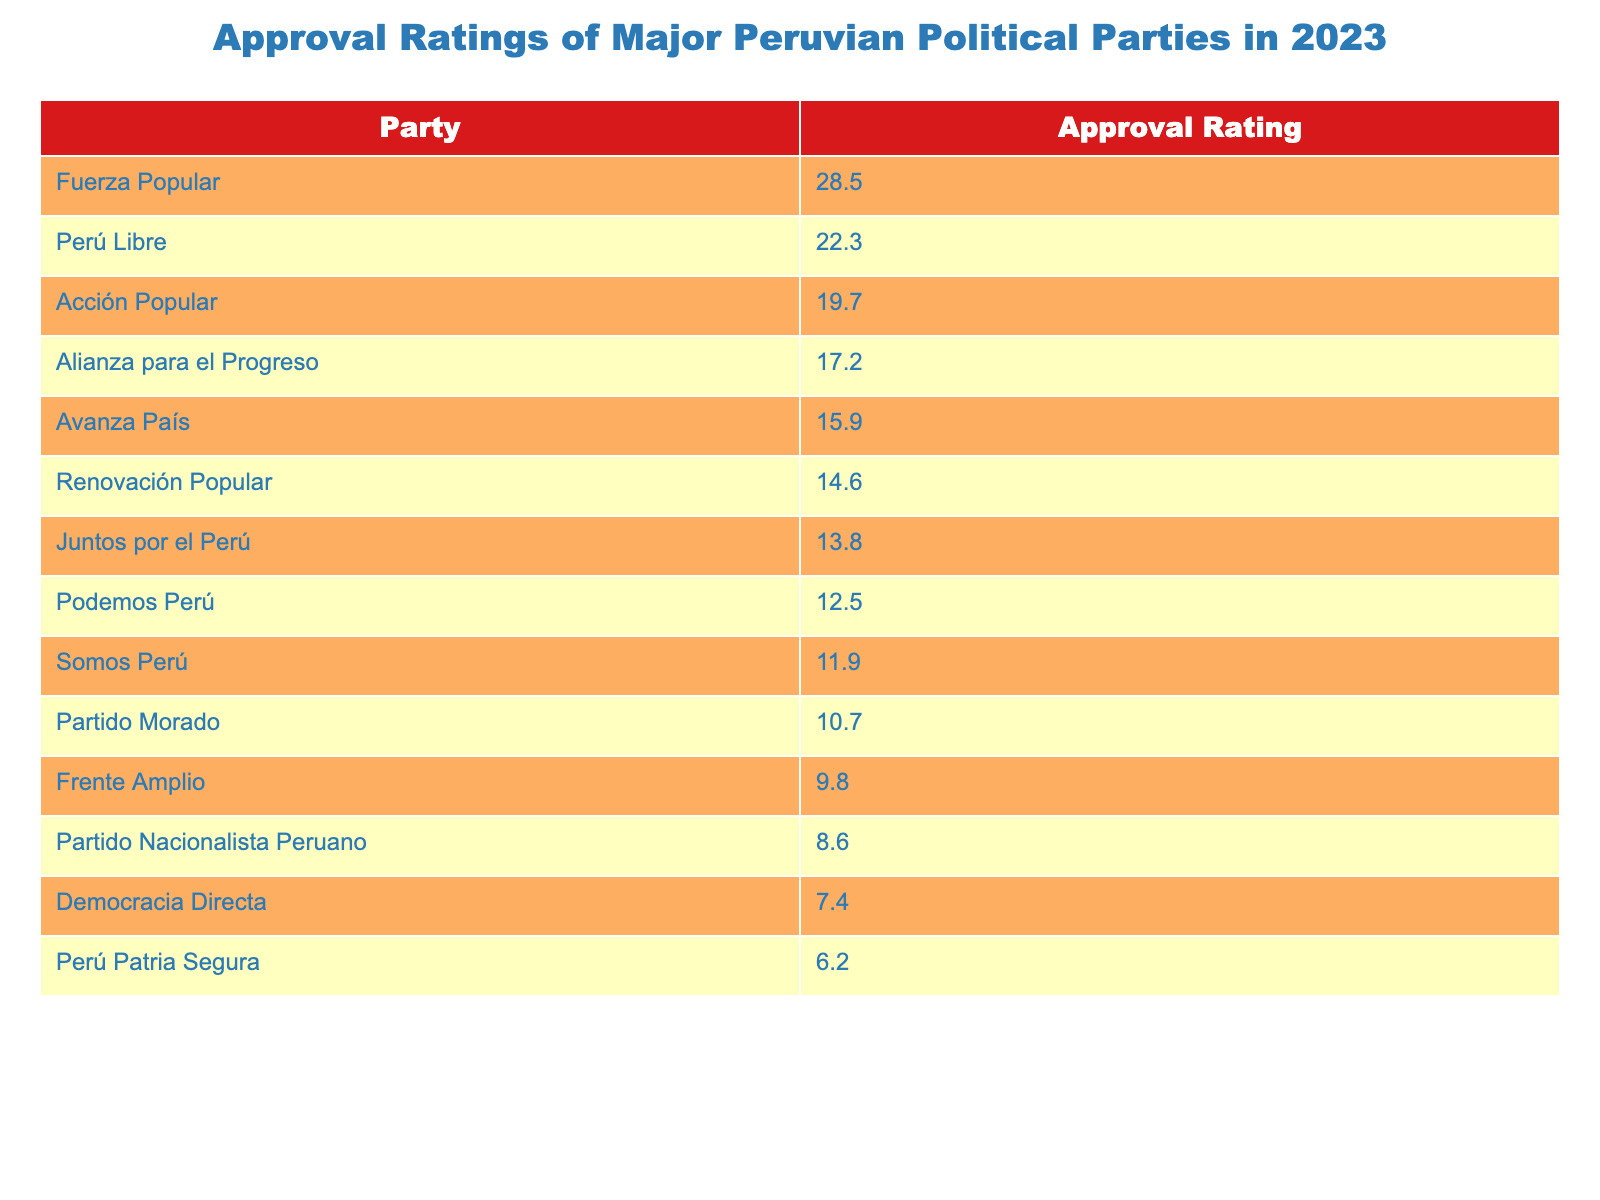What is the approval rating of Fuerza Popular? The table lists the approval rating for Fuerza Popular as 28.5.
Answer: 28.5 Which party has the lowest approval rating? By looking through the table, I find that Perú Patria Segura has the lowest approval rating at 6.2.
Answer: 6.2 What are the approval ratings of Alianza para el Progreso and Avanza País combined? The approval rating for Alianza para el Progreso is 17.2 and for Avanza País is 15.9. Summing these together gives 17.2 + 15.9 = 33.1.
Answer: 33.1 Is the approval rating of Juntos por el Perú higher than that of Podemos Perú? Juntos por el Perú has an approval rating of 13.8, while Podemos Perú has 12.5. Since 13.8 is greater than 12.5, the statement is true.
Answer: Yes What is the average approval rating of the parties listed in the table? To calculate the average, sum the approval ratings: (28.5 + 22.3 + 19.7 + 17.2 + 15.9 + 14.6 + 13.8 + 12.5 + 11.9 + 10.7 + 9.8 + 8.6 + 7.4 + 6.2) =  267.2. There are 14 parties, so the average is 267.2 / 14 = 19.1.
Answer: 19.1 How many parties have an approval rating above 20? By examining the table, I see that the parties with approval ratings above 20 are Fuerza Popular (28.5) and Perú Libre (22.3), which makes a total of 2 parties.
Answer: 2 What is the difference in approval ratings between Acción Popular and Renovación Popular? Acción Popular has an approval rating of 19.7 and Renovación Popular has 14.6. The difference is calculated as 19.7 - 14.6 = 5.1.
Answer: 5.1 Which party's approval rating is closer to 15? The closest approval rating to 15 is Avanza País at 15.9. Since it is the only one near 15, it can be concluded that it is the one being referred to.
Answer: Avanza País Is the approval rating of Partido Morado greater than the average of the top three parties? The top three parties are Fuerza Popular (28.5), Perú Libre (22.3), and Acción Popular (19.7). Their average is (28.5 + 22.3 + 19.7) / 3 = 23.5. Partido Morado has an approval rating of 10.7, which is not greater than 23.5.
Answer: No What party has an approval rating that is exactly half of Fuerza Popular's rating? Fuerza Popular's rating is 28.5, making half of that 14.25. The closest party with that rating is Renovación Popular at 14.6. None are exactly 14.25, but Renovación Popular is the nearest option.
Answer: Renovación Popular How many parties have an approval rating below the average value you calculated? The average approval rating calculated previously is 19.1. The parties with ratings below this are Alianza para el Progreso (17.2), Avanza País (15.9), Renovación Popular (14.6), Juntos por el Perú (13.8), Podemos Perú (12.5), Somos Perú (11.9), Partido Morado (10.7), Frente Amplio (9.8), Partido Nacionalista Peruano (8.6), Democracia Directa (7.4), and Perú Patria Segura (6.2). Counting these, a total of 11 parties have ratings below the average.
Answer: 11 